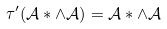<formula> <loc_0><loc_0><loc_500><loc_500>\tau ^ { \prime } ( \mathcal { A } \ast \wedge \mathcal { A } ) = \mathcal { A } \ast \wedge \mathcal { A } \,</formula> 